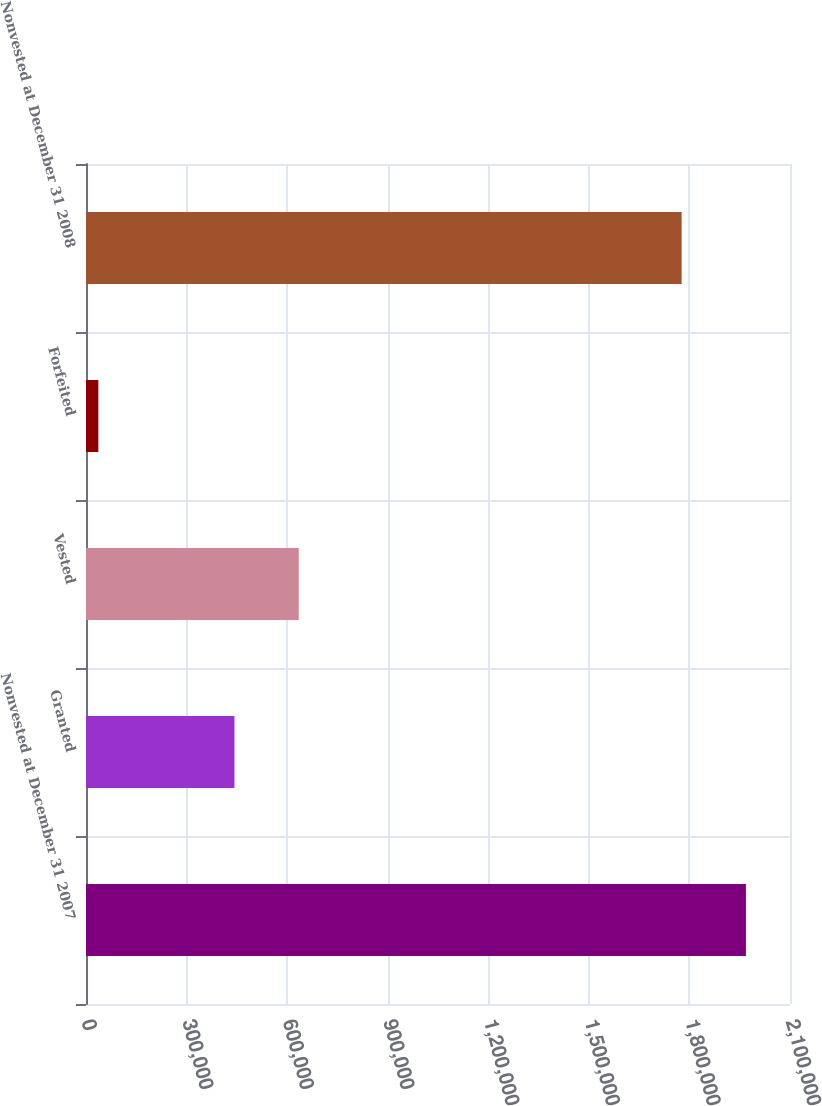Convert chart. <chart><loc_0><loc_0><loc_500><loc_500><bar_chart><fcel>Nonvested at December 31 2007<fcel>Granted<fcel>Vested<fcel>Forfeited<fcel>Nonvested at December 31 2008<nl><fcel>1.96857e+06<fcel>442865<fcel>634647<fcel>36852<fcel>1.77679e+06<nl></chart> 